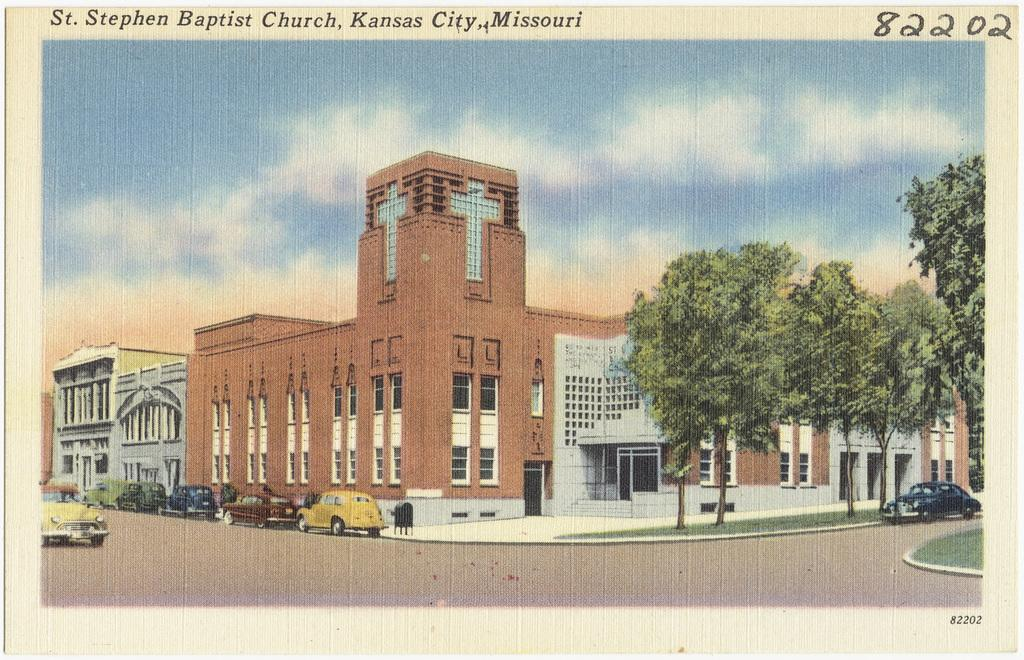What is present on the paper in the image? There are words and numbers on the paper. What can be seen on the road in the image? There are vehicles on the road in the image. What type of structures are visible in the image? There are buildings in the image. What other natural elements can be seen in the image? There are trees in the image. What is visible in the background of the image? The sky is visible in the background of the image. Can you tell me how many frogs are sitting on the metal mailbox in the image? There are no frogs or mailboxes present in the image. What type of metal is used to construct the mailbox in the image? There is no mailbox present in the image, so it is not possible to determine the type of metal used. 